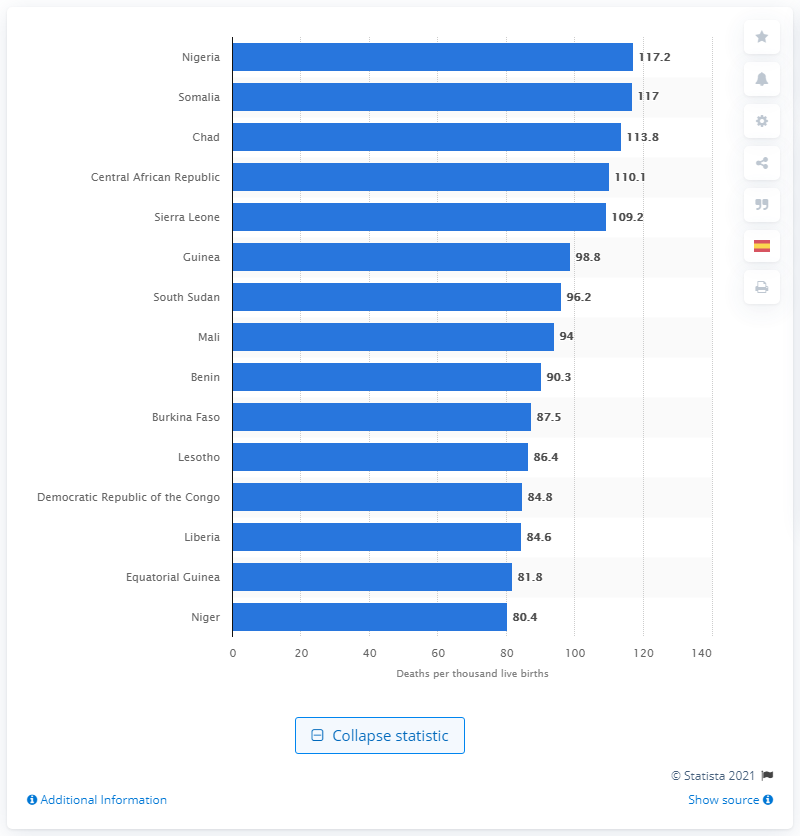Draw attention to some important aspects in this diagram. Nigeria had the highest mortality rate among children under the age of five in the year 2020, according to data from the World Health Organization. 